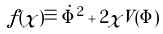<formula> <loc_0><loc_0><loc_500><loc_500>f ( \chi ) \equiv \dot { \Phi } ^ { 2 } + 2 \chi V ( \Phi )</formula> 